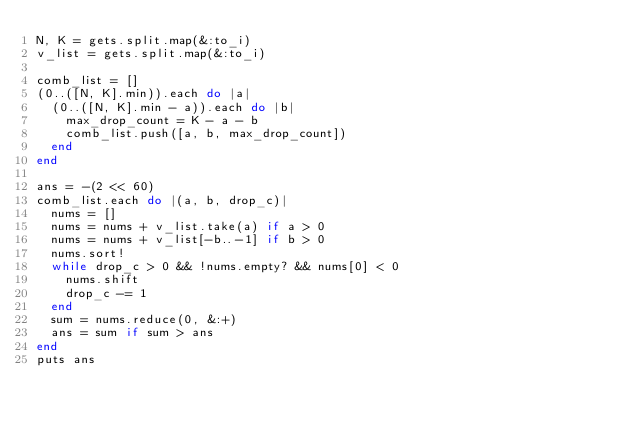<code> <loc_0><loc_0><loc_500><loc_500><_Ruby_>N, K = gets.split.map(&:to_i)
v_list = gets.split.map(&:to_i)

comb_list = []
(0..([N, K].min)).each do |a|
  (0..([N, K].min - a)).each do |b|
    max_drop_count = K - a - b
    comb_list.push([a, b, max_drop_count])
  end
end

ans = -(2 << 60)
comb_list.each do |(a, b, drop_c)|
  nums = []
  nums = nums + v_list.take(a) if a > 0
  nums = nums + v_list[-b..-1] if b > 0
  nums.sort!
  while drop_c > 0 && !nums.empty? && nums[0] < 0
    nums.shift
    drop_c -= 1
  end
  sum = nums.reduce(0, &:+)
  ans = sum if sum > ans
end
puts ans
</code> 